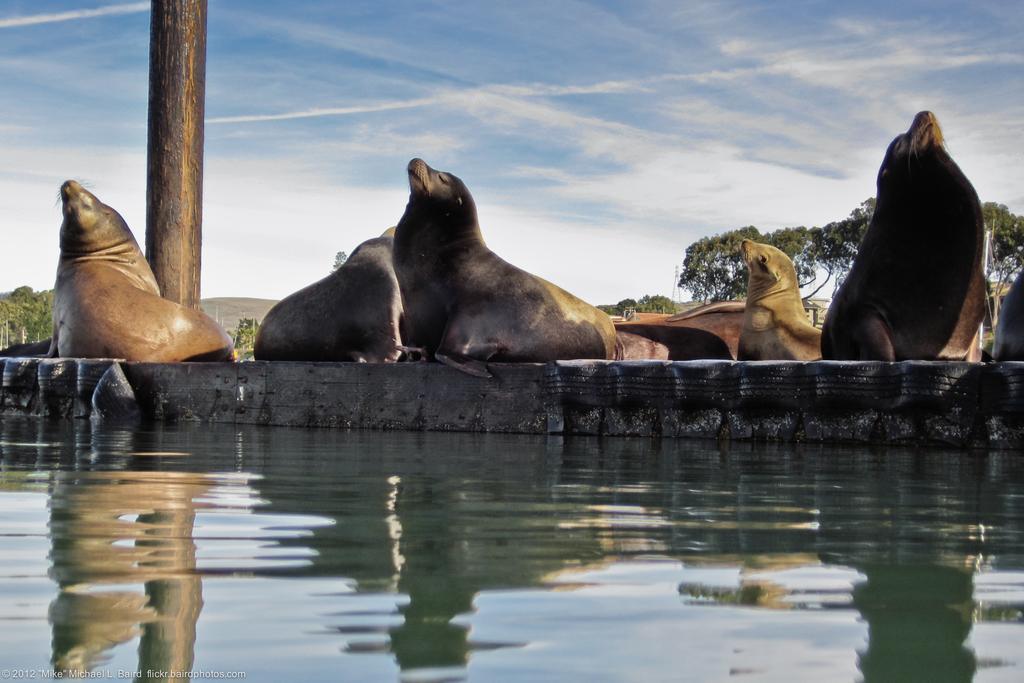Please provide a concise description of this image. This image is taken outdoors. At the bottom of the image there is a pond with water. At the top of the image there is a sky with clouds. In the background there are many trees. In the middle of the image there are many seals on the floor and there is a pole. 